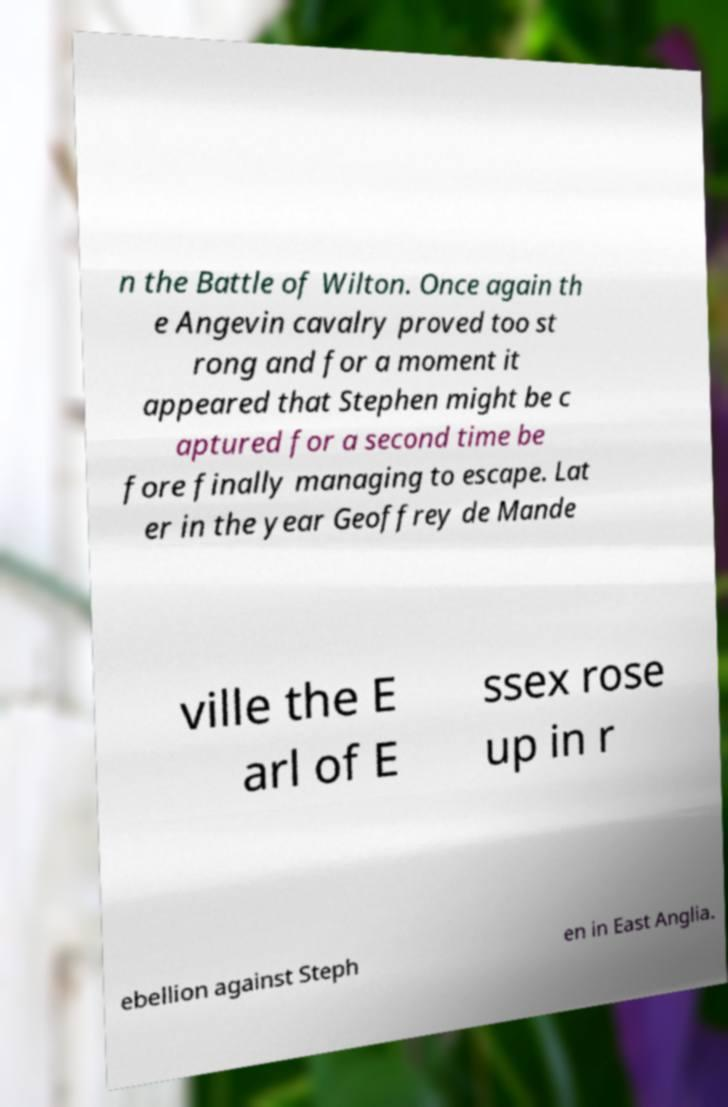Could you assist in decoding the text presented in this image and type it out clearly? n the Battle of Wilton. Once again th e Angevin cavalry proved too st rong and for a moment it appeared that Stephen might be c aptured for a second time be fore finally managing to escape. Lat er in the year Geoffrey de Mande ville the E arl of E ssex rose up in r ebellion against Steph en in East Anglia. 